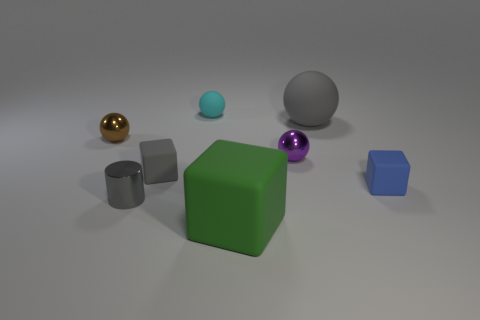Is there anything else that has the same shape as the tiny gray shiny object?
Your answer should be compact. No. There is a cyan rubber sphere behind the blue object; does it have the same size as the small gray cylinder?
Offer a very short reply. Yes. What number of metallic objects are either tiny yellow things or cyan balls?
Give a very brief answer. 0. What is the size of the rubber ball that is right of the small cyan ball?
Your answer should be very brief. Large. Do the small cyan matte object and the blue thing have the same shape?
Offer a very short reply. No. How many small things are either brown metallic cubes or purple shiny objects?
Provide a succinct answer. 1. There is a green object; are there any brown metal balls to the left of it?
Your response must be concise. Yes. Is the number of green rubber cubes that are behind the large green matte block the same as the number of yellow metal cylinders?
Your response must be concise. Yes. What is the size of the other rubber object that is the same shape as the cyan object?
Ensure brevity in your answer.  Large. There is a small purple shiny thing; is its shape the same as the small blue object that is right of the tiny brown thing?
Offer a terse response. No. 